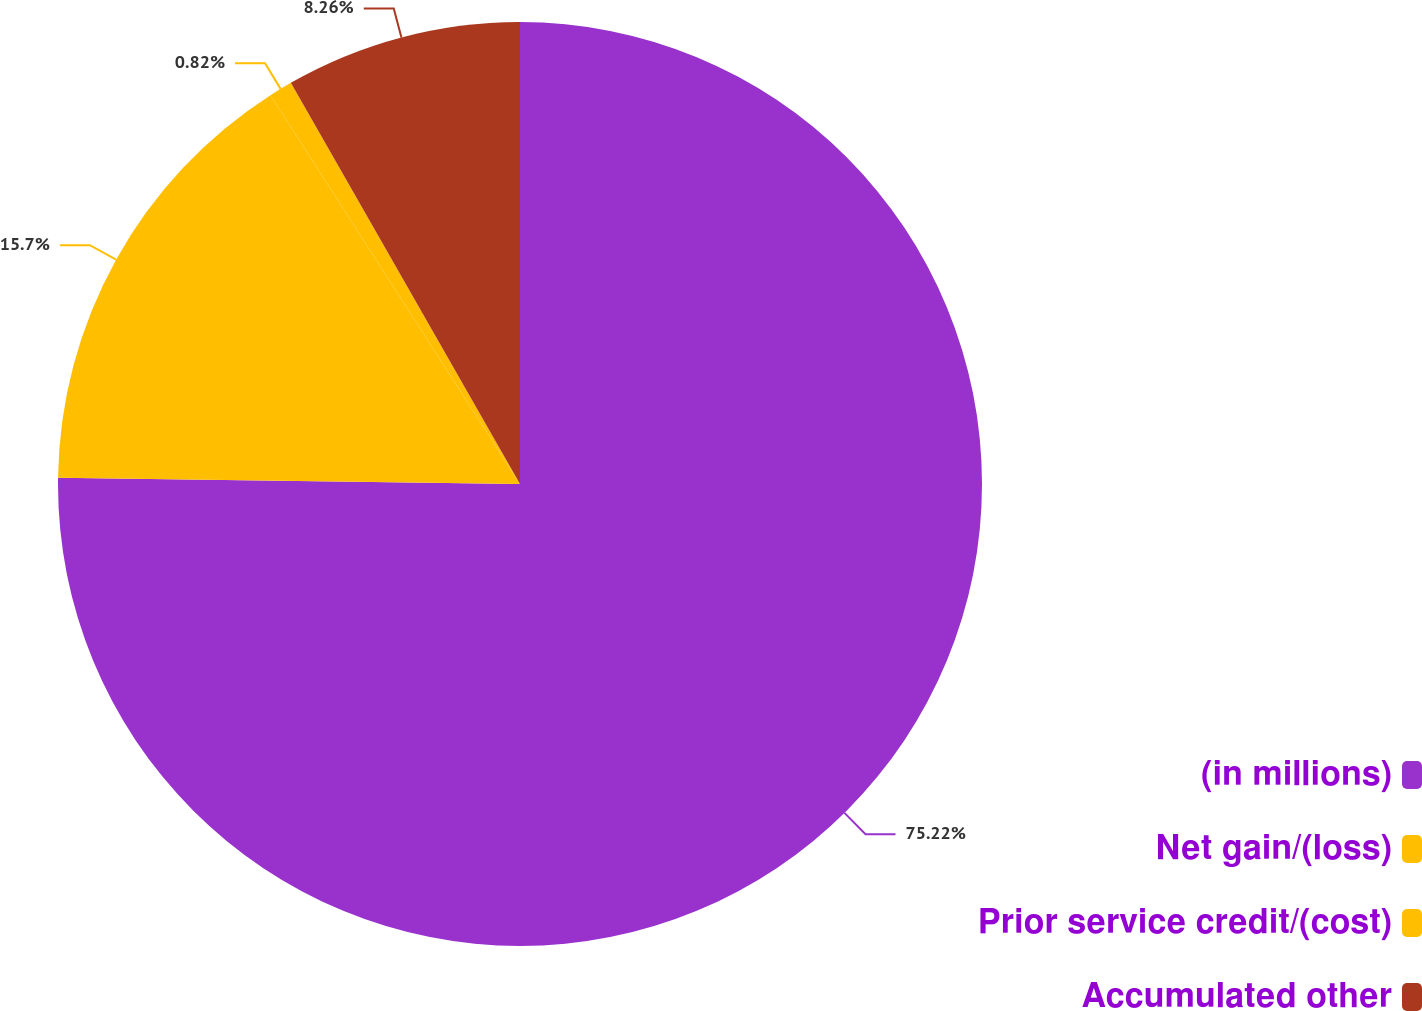Convert chart. <chart><loc_0><loc_0><loc_500><loc_500><pie_chart><fcel>(in millions)<fcel>Net gain/(loss)<fcel>Prior service credit/(cost)<fcel>Accumulated other<nl><fcel>75.21%<fcel>15.7%<fcel>0.82%<fcel>8.26%<nl></chart> 